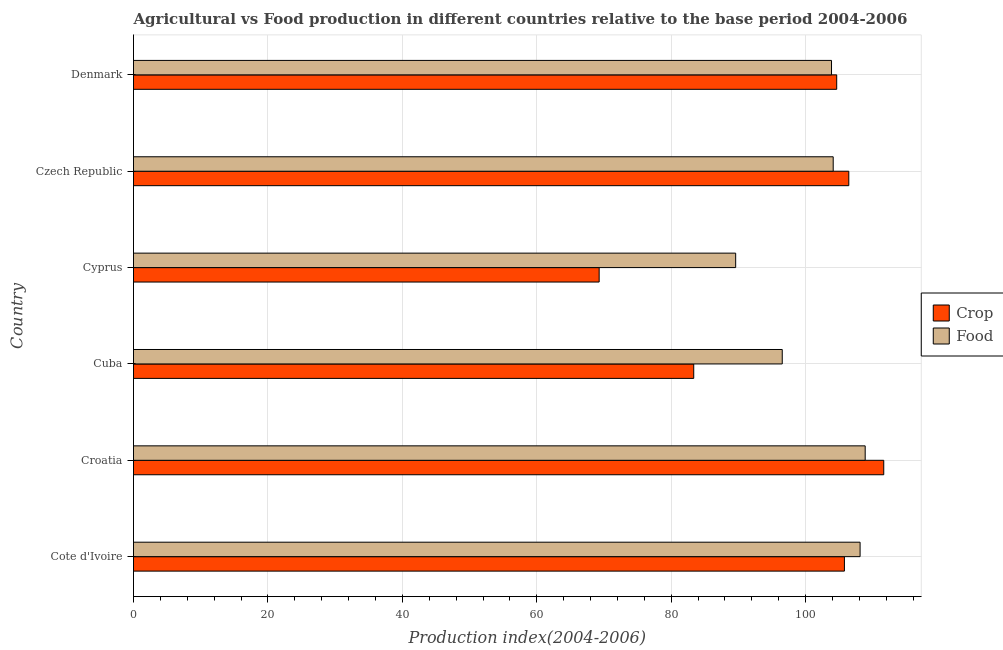Are the number of bars on each tick of the Y-axis equal?
Keep it short and to the point. Yes. How many bars are there on the 1st tick from the bottom?
Keep it short and to the point. 2. What is the label of the 4th group of bars from the top?
Provide a succinct answer. Cuba. What is the crop production index in Croatia?
Provide a short and direct response. 111.62. Across all countries, what is the maximum crop production index?
Ensure brevity in your answer.  111.62. Across all countries, what is the minimum crop production index?
Provide a succinct answer. 69.28. In which country was the food production index maximum?
Provide a short and direct response. Croatia. In which country was the food production index minimum?
Ensure brevity in your answer.  Cyprus. What is the total food production index in the graph?
Keep it short and to the point. 611.02. What is the difference between the food production index in Cuba and that in Cyprus?
Your answer should be compact. 6.93. What is the difference between the food production index in Czech Republic and the crop production index in Croatia?
Offer a terse response. -7.52. What is the average food production index per country?
Your response must be concise. 101.84. What is the difference between the food production index and crop production index in Cuba?
Offer a very short reply. 13.17. In how many countries, is the food production index greater than 60 ?
Make the answer very short. 6. What is the ratio of the food production index in Cote d'Ivoire to that in Cyprus?
Make the answer very short. 1.21. Is the crop production index in Croatia less than that in Cuba?
Ensure brevity in your answer.  No. What is the difference between the highest and the second highest food production index?
Offer a very short reply. 0.76. What is the difference between the highest and the lowest crop production index?
Make the answer very short. 42.34. What does the 2nd bar from the top in Cote d'Ivoire represents?
Your answer should be very brief. Crop. What does the 1st bar from the bottom in Cyprus represents?
Give a very brief answer. Crop. How many bars are there?
Your answer should be compact. 12. Are all the bars in the graph horizontal?
Give a very brief answer. Yes. What is the difference between two consecutive major ticks on the X-axis?
Offer a very short reply. 20. Are the values on the major ticks of X-axis written in scientific E-notation?
Provide a short and direct response. No. Does the graph contain any zero values?
Make the answer very short. No. How many legend labels are there?
Ensure brevity in your answer.  2. How are the legend labels stacked?
Your answer should be compact. Vertical. What is the title of the graph?
Offer a very short reply. Agricultural vs Food production in different countries relative to the base period 2004-2006. What is the label or title of the X-axis?
Offer a very short reply. Production index(2004-2006). What is the Production index(2004-2006) of Crop in Cote d'Ivoire?
Your answer should be compact. 105.77. What is the Production index(2004-2006) of Food in Cote d'Ivoire?
Offer a very short reply. 108.1. What is the Production index(2004-2006) of Crop in Croatia?
Give a very brief answer. 111.62. What is the Production index(2004-2006) in Food in Croatia?
Make the answer very short. 108.86. What is the Production index(2004-2006) in Crop in Cuba?
Give a very brief answer. 83.35. What is the Production index(2004-2006) of Food in Cuba?
Give a very brief answer. 96.52. What is the Production index(2004-2006) of Crop in Cyprus?
Give a very brief answer. 69.28. What is the Production index(2004-2006) of Food in Cyprus?
Give a very brief answer. 89.59. What is the Production index(2004-2006) of Crop in Czech Republic?
Make the answer very short. 106.42. What is the Production index(2004-2006) in Food in Czech Republic?
Keep it short and to the point. 104.1. What is the Production index(2004-2006) in Crop in Denmark?
Offer a very short reply. 104.62. What is the Production index(2004-2006) of Food in Denmark?
Your answer should be compact. 103.85. Across all countries, what is the maximum Production index(2004-2006) in Crop?
Make the answer very short. 111.62. Across all countries, what is the maximum Production index(2004-2006) of Food?
Provide a succinct answer. 108.86. Across all countries, what is the minimum Production index(2004-2006) in Crop?
Provide a succinct answer. 69.28. Across all countries, what is the minimum Production index(2004-2006) in Food?
Provide a short and direct response. 89.59. What is the total Production index(2004-2006) in Crop in the graph?
Ensure brevity in your answer.  581.06. What is the total Production index(2004-2006) in Food in the graph?
Your answer should be compact. 611.02. What is the difference between the Production index(2004-2006) of Crop in Cote d'Ivoire and that in Croatia?
Your answer should be compact. -5.85. What is the difference between the Production index(2004-2006) in Food in Cote d'Ivoire and that in Croatia?
Offer a terse response. -0.76. What is the difference between the Production index(2004-2006) in Crop in Cote d'Ivoire and that in Cuba?
Provide a short and direct response. 22.42. What is the difference between the Production index(2004-2006) in Food in Cote d'Ivoire and that in Cuba?
Your response must be concise. 11.58. What is the difference between the Production index(2004-2006) of Crop in Cote d'Ivoire and that in Cyprus?
Your answer should be very brief. 36.49. What is the difference between the Production index(2004-2006) in Food in Cote d'Ivoire and that in Cyprus?
Provide a short and direct response. 18.51. What is the difference between the Production index(2004-2006) of Crop in Cote d'Ivoire and that in Czech Republic?
Your answer should be compact. -0.65. What is the difference between the Production index(2004-2006) of Food in Cote d'Ivoire and that in Czech Republic?
Offer a terse response. 4. What is the difference between the Production index(2004-2006) in Crop in Cote d'Ivoire and that in Denmark?
Make the answer very short. 1.15. What is the difference between the Production index(2004-2006) of Food in Cote d'Ivoire and that in Denmark?
Your response must be concise. 4.25. What is the difference between the Production index(2004-2006) of Crop in Croatia and that in Cuba?
Your answer should be compact. 28.27. What is the difference between the Production index(2004-2006) of Food in Croatia and that in Cuba?
Ensure brevity in your answer.  12.34. What is the difference between the Production index(2004-2006) of Crop in Croatia and that in Cyprus?
Your response must be concise. 42.34. What is the difference between the Production index(2004-2006) in Food in Croatia and that in Cyprus?
Your answer should be very brief. 19.27. What is the difference between the Production index(2004-2006) in Food in Croatia and that in Czech Republic?
Ensure brevity in your answer.  4.76. What is the difference between the Production index(2004-2006) of Crop in Croatia and that in Denmark?
Your response must be concise. 7. What is the difference between the Production index(2004-2006) of Food in Croatia and that in Denmark?
Provide a succinct answer. 5.01. What is the difference between the Production index(2004-2006) of Crop in Cuba and that in Cyprus?
Offer a terse response. 14.07. What is the difference between the Production index(2004-2006) of Food in Cuba and that in Cyprus?
Ensure brevity in your answer.  6.93. What is the difference between the Production index(2004-2006) in Crop in Cuba and that in Czech Republic?
Your answer should be compact. -23.07. What is the difference between the Production index(2004-2006) in Food in Cuba and that in Czech Republic?
Offer a very short reply. -7.58. What is the difference between the Production index(2004-2006) in Crop in Cuba and that in Denmark?
Ensure brevity in your answer.  -21.27. What is the difference between the Production index(2004-2006) of Food in Cuba and that in Denmark?
Give a very brief answer. -7.33. What is the difference between the Production index(2004-2006) of Crop in Cyprus and that in Czech Republic?
Your answer should be very brief. -37.14. What is the difference between the Production index(2004-2006) of Food in Cyprus and that in Czech Republic?
Provide a succinct answer. -14.51. What is the difference between the Production index(2004-2006) in Crop in Cyprus and that in Denmark?
Provide a short and direct response. -35.34. What is the difference between the Production index(2004-2006) in Food in Cyprus and that in Denmark?
Provide a succinct answer. -14.26. What is the difference between the Production index(2004-2006) of Crop in Czech Republic and that in Denmark?
Keep it short and to the point. 1.8. What is the difference between the Production index(2004-2006) of Food in Czech Republic and that in Denmark?
Offer a very short reply. 0.25. What is the difference between the Production index(2004-2006) of Crop in Cote d'Ivoire and the Production index(2004-2006) of Food in Croatia?
Offer a very short reply. -3.09. What is the difference between the Production index(2004-2006) in Crop in Cote d'Ivoire and the Production index(2004-2006) in Food in Cuba?
Your response must be concise. 9.25. What is the difference between the Production index(2004-2006) of Crop in Cote d'Ivoire and the Production index(2004-2006) of Food in Cyprus?
Offer a terse response. 16.18. What is the difference between the Production index(2004-2006) in Crop in Cote d'Ivoire and the Production index(2004-2006) in Food in Czech Republic?
Your answer should be compact. 1.67. What is the difference between the Production index(2004-2006) in Crop in Cote d'Ivoire and the Production index(2004-2006) in Food in Denmark?
Ensure brevity in your answer.  1.92. What is the difference between the Production index(2004-2006) in Crop in Croatia and the Production index(2004-2006) in Food in Cyprus?
Provide a short and direct response. 22.03. What is the difference between the Production index(2004-2006) of Crop in Croatia and the Production index(2004-2006) of Food in Czech Republic?
Your answer should be compact. 7.52. What is the difference between the Production index(2004-2006) of Crop in Croatia and the Production index(2004-2006) of Food in Denmark?
Provide a short and direct response. 7.77. What is the difference between the Production index(2004-2006) in Crop in Cuba and the Production index(2004-2006) in Food in Cyprus?
Your answer should be compact. -6.24. What is the difference between the Production index(2004-2006) in Crop in Cuba and the Production index(2004-2006) in Food in Czech Republic?
Offer a very short reply. -20.75. What is the difference between the Production index(2004-2006) of Crop in Cuba and the Production index(2004-2006) of Food in Denmark?
Offer a very short reply. -20.5. What is the difference between the Production index(2004-2006) in Crop in Cyprus and the Production index(2004-2006) in Food in Czech Republic?
Give a very brief answer. -34.82. What is the difference between the Production index(2004-2006) in Crop in Cyprus and the Production index(2004-2006) in Food in Denmark?
Provide a short and direct response. -34.57. What is the difference between the Production index(2004-2006) in Crop in Czech Republic and the Production index(2004-2006) in Food in Denmark?
Ensure brevity in your answer.  2.57. What is the average Production index(2004-2006) in Crop per country?
Offer a very short reply. 96.84. What is the average Production index(2004-2006) of Food per country?
Provide a short and direct response. 101.84. What is the difference between the Production index(2004-2006) of Crop and Production index(2004-2006) of Food in Cote d'Ivoire?
Your answer should be compact. -2.33. What is the difference between the Production index(2004-2006) of Crop and Production index(2004-2006) of Food in Croatia?
Your answer should be very brief. 2.76. What is the difference between the Production index(2004-2006) in Crop and Production index(2004-2006) in Food in Cuba?
Your response must be concise. -13.17. What is the difference between the Production index(2004-2006) in Crop and Production index(2004-2006) in Food in Cyprus?
Keep it short and to the point. -20.31. What is the difference between the Production index(2004-2006) in Crop and Production index(2004-2006) in Food in Czech Republic?
Provide a short and direct response. 2.32. What is the difference between the Production index(2004-2006) in Crop and Production index(2004-2006) in Food in Denmark?
Your answer should be very brief. 0.77. What is the ratio of the Production index(2004-2006) in Crop in Cote d'Ivoire to that in Croatia?
Ensure brevity in your answer.  0.95. What is the ratio of the Production index(2004-2006) in Crop in Cote d'Ivoire to that in Cuba?
Ensure brevity in your answer.  1.27. What is the ratio of the Production index(2004-2006) in Food in Cote d'Ivoire to that in Cuba?
Keep it short and to the point. 1.12. What is the ratio of the Production index(2004-2006) of Crop in Cote d'Ivoire to that in Cyprus?
Offer a terse response. 1.53. What is the ratio of the Production index(2004-2006) in Food in Cote d'Ivoire to that in Cyprus?
Your answer should be compact. 1.21. What is the ratio of the Production index(2004-2006) of Crop in Cote d'Ivoire to that in Czech Republic?
Provide a short and direct response. 0.99. What is the ratio of the Production index(2004-2006) of Food in Cote d'Ivoire to that in Czech Republic?
Give a very brief answer. 1.04. What is the ratio of the Production index(2004-2006) in Crop in Cote d'Ivoire to that in Denmark?
Offer a terse response. 1.01. What is the ratio of the Production index(2004-2006) of Food in Cote d'Ivoire to that in Denmark?
Your answer should be compact. 1.04. What is the ratio of the Production index(2004-2006) in Crop in Croatia to that in Cuba?
Your answer should be very brief. 1.34. What is the ratio of the Production index(2004-2006) in Food in Croatia to that in Cuba?
Make the answer very short. 1.13. What is the ratio of the Production index(2004-2006) in Crop in Croatia to that in Cyprus?
Provide a succinct answer. 1.61. What is the ratio of the Production index(2004-2006) in Food in Croatia to that in Cyprus?
Ensure brevity in your answer.  1.22. What is the ratio of the Production index(2004-2006) of Crop in Croatia to that in Czech Republic?
Your response must be concise. 1.05. What is the ratio of the Production index(2004-2006) of Food in Croatia to that in Czech Republic?
Provide a succinct answer. 1.05. What is the ratio of the Production index(2004-2006) of Crop in Croatia to that in Denmark?
Provide a succinct answer. 1.07. What is the ratio of the Production index(2004-2006) in Food in Croatia to that in Denmark?
Offer a very short reply. 1.05. What is the ratio of the Production index(2004-2006) of Crop in Cuba to that in Cyprus?
Provide a succinct answer. 1.2. What is the ratio of the Production index(2004-2006) in Food in Cuba to that in Cyprus?
Provide a succinct answer. 1.08. What is the ratio of the Production index(2004-2006) of Crop in Cuba to that in Czech Republic?
Offer a very short reply. 0.78. What is the ratio of the Production index(2004-2006) in Food in Cuba to that in Czech Republic?
Offer a very short reply. 0.93. What is the ratio of the Production index(2004-2006) in Crop in Cuba to that in Denmark?
Provide a succinct answer. 0.8. What is the ratio of the Production index(2004-2006) of Food in Cuba to that in Denmark?
Your answer should be very brief. 0.93. What is the ratio of the Production index(2004-2006) of Crop in Cyprus to that in Czech Republic?
Ensure brevity in your answer.  0.65. What is the ratio of the Production index(2004-2006) in Food in Cyprus to that in Czech Republic?
Offer a very short reply. 0.86. What is the ratio of the Production index(2004-2006) in Crop in Cyprus to that in Denmark?
Keep it short and to the point. 0.66. What is the ratio of the Production index(2004-2006) in Food in Cyprus to that in Denmark?
Offer a very short reply. 0.86. What is the ratio of the Production index(2004-2006) in Crop in Czech Republic to that in Denmark?
Keep it short and to the point. 1.02. What is the ratio of the Production index(2004-2006) in Food in Czech Republic to that in Denmark?
Offer a terse response. 1. What is the difference between the highest and the second highest Production index(2004-2006) of Crop?
Provide a succinct answer. 5.2. What is the difference between the highest and the second highest Production index(2004-2006) in Food?
Your response must be concise. 0.76. What is the difference between the highest and the lowest Production index(2004-2006) of Crop?
Your answer should be compact. 42.34. What is the difference between the highest and the lowest Production index(2004-2006) of Food?
Give a very brief answer. 19.27. 